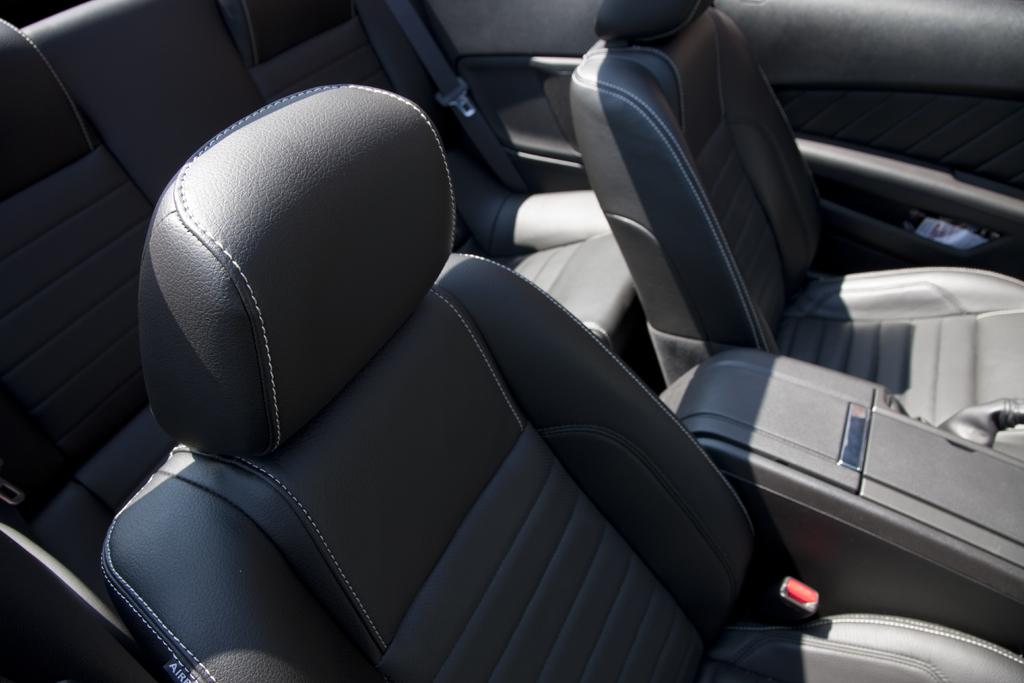What type of furniture is visible in the image? There are seats in the image. What safety feature is associated with the seats? There are seat belts in the image. Can you describe any other objects present in the image? There are some unspecified objects in the image. What type of pleasure can be seen being derived from the faucet in the image? There is no faucet present in the image, so it is not possible to determine any pleasure derived from it. 